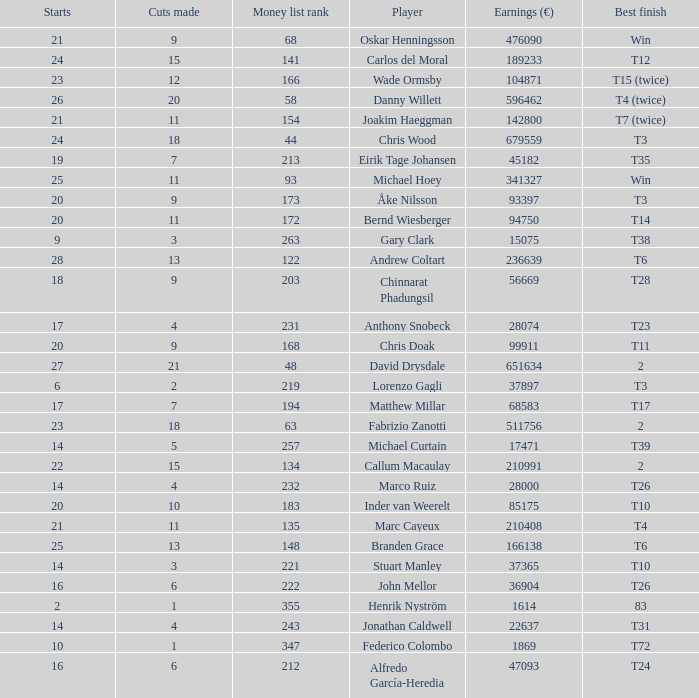How many cuts did the player who earned 210408 Euro make? 11.0. 